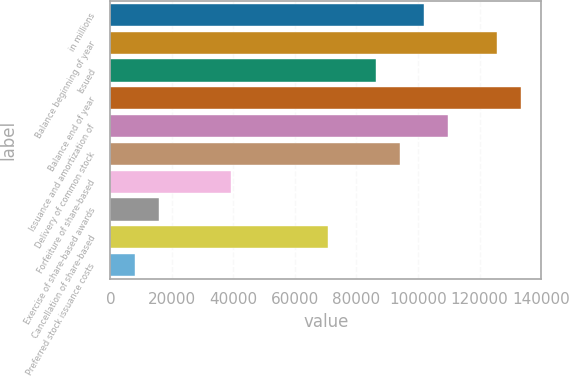Convert chart to OTSL. <chart><loc_0><loc_0><loc_500><loc_500><bar_chart><fcel>in millions<fcel>Balance beginning of year<fcel>Issued<fcel>Balance end of year<fcel>Issuance and amortization of<fcel>Delivery of common stock<fcel>Forfeiture of share-based<fcel>Exercise of share-based awards<fcel>Cancellation of share-based<fcel>Preferred stock issuance costs<nl><fcel>102007<fcel>125547<fcel>86313.6<fcel>133393<fcel>109853<fcel>94160.2<fcel>39234<fcel>15694.2<fcel>70620.4<fcel>7847.6<nl></chart> 